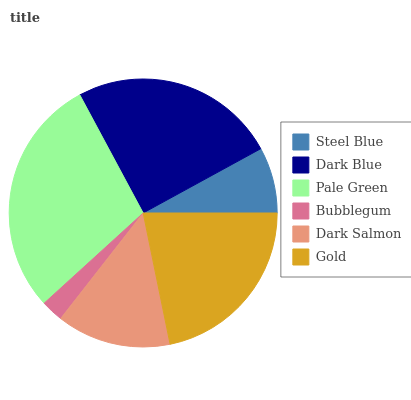Is Bubblegum the minimum?
Answer yes or no. Yes. Is Pale Green the maximum?
Answer yes or no. Yes. Is Dark Blue the minimum?
Answer yes or no. No. Is Dark Blue the maximum?
Answer yes or no. No. Is Dark Blue greater than Steel Blue?
Answer yes or no. Yes. Is Steel Blue less than Dark Blue?
Answer yes or no. Yes. Is Steel Blue greater than Dark Blue?
Answer yes or no. No. Is Dark Blue less than Steel Blue?
Answer yes or no. No. Is Gold the high median?
Answer yes or no. Yes. Is Dark Salmon the low median?
Answer yes or no. Yes. Is Dark Salmon the high median?
Answer yes or no. No. Is Bubblegum the low median?
Answer yes or no. No. 